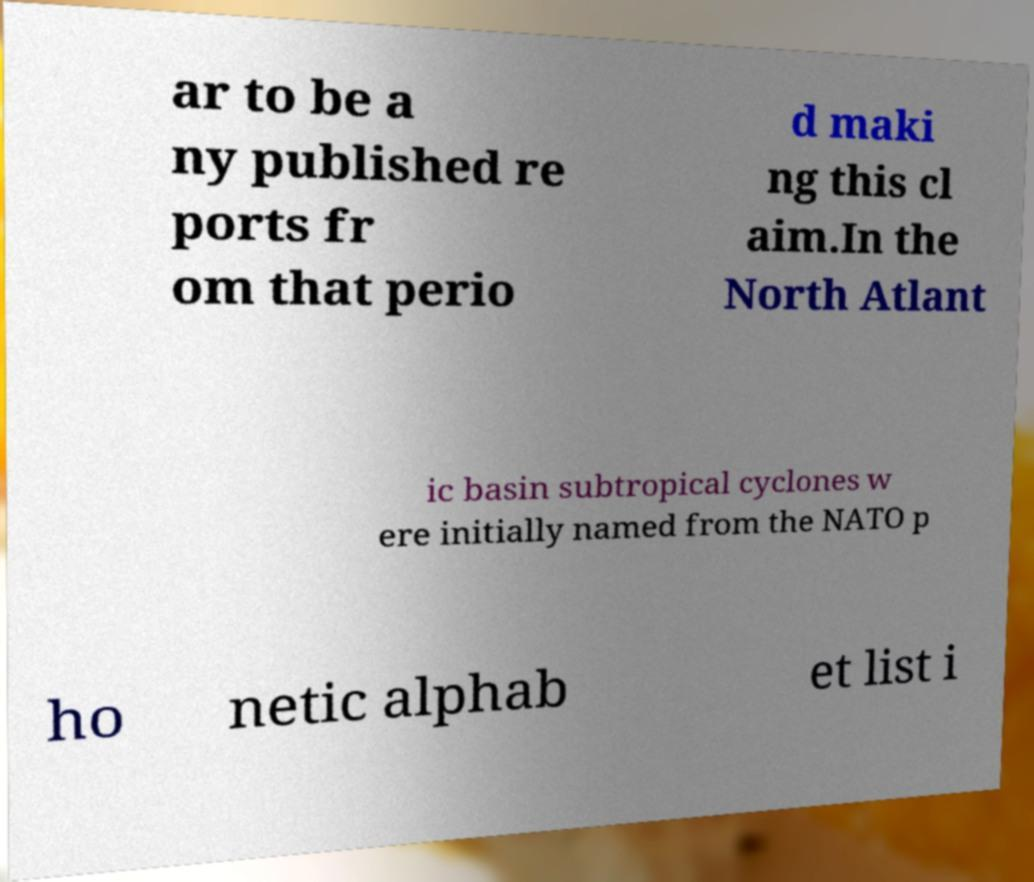Can you accurately transcribe the text from the provided image for me? ar to be a ny published re ports fr om that perio d maki ng this cl aim.In the North Atlant ic basin subtropical cyclones w ere initially named from the NATO p ho netic alphab et list i 